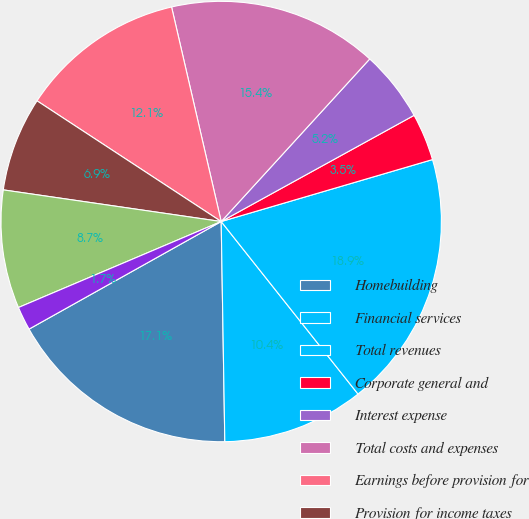Convert chart. <chart><loc_0><loc_0><loc_500><loc_500><pie_chart><fcel>Homebuilding<fcel>Financial services<fcel>Total revenues<fcel>Corporate general and<fcel>Interest expense<fcel>Total costs and expenses<fcel>Earnings before provision for<fcel>Provision for income taxes<fcel>Net earnings<fcel>Basic<nl><fcel>17.14%<fcel>10.41%<fcel>18.87%<fcel>3.47%<fcel>5.21%<fcel>15.4%<fcel>12.15%<fcel>6.94%<fcel>8.68%<fcel>1.74%<nl></chart> 